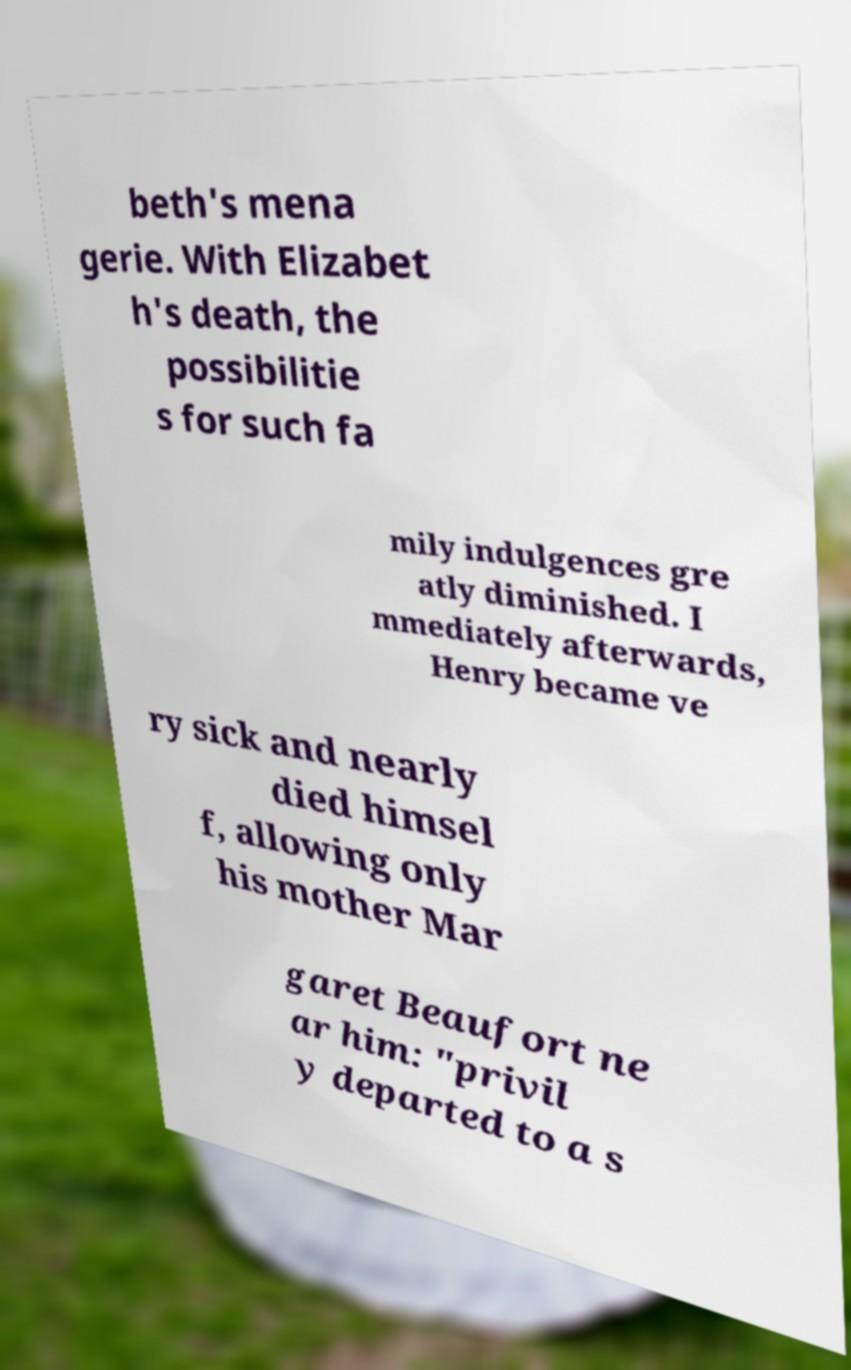I need the written content from this picture converted into text. Can you do that? beth's mena gerie. With Elizabet h's death, the possibilitie s for such fa mily indulgences gre atly diminished. I mmediately afterwards, Henry became ve ry sick and nearly died himsel f, allowing only his mother Mar garet Beaufort ne ar him: "privil y departed to a s 